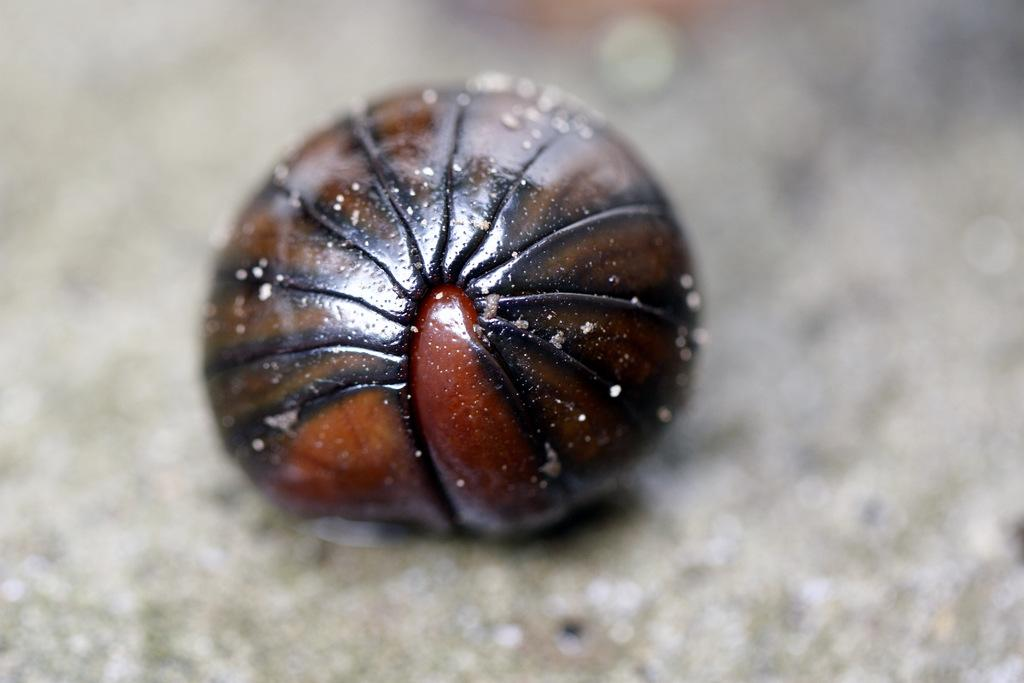What colors are present in the object in the image? The object in the image has black and brown colors. Can you describe the background of the image? The background of the image is blurred. Is there a notebook visible in the image? There is no mention of a notebook in the provided facts, so it cannot be confirmed or denied whether a notebook is present in the image. 